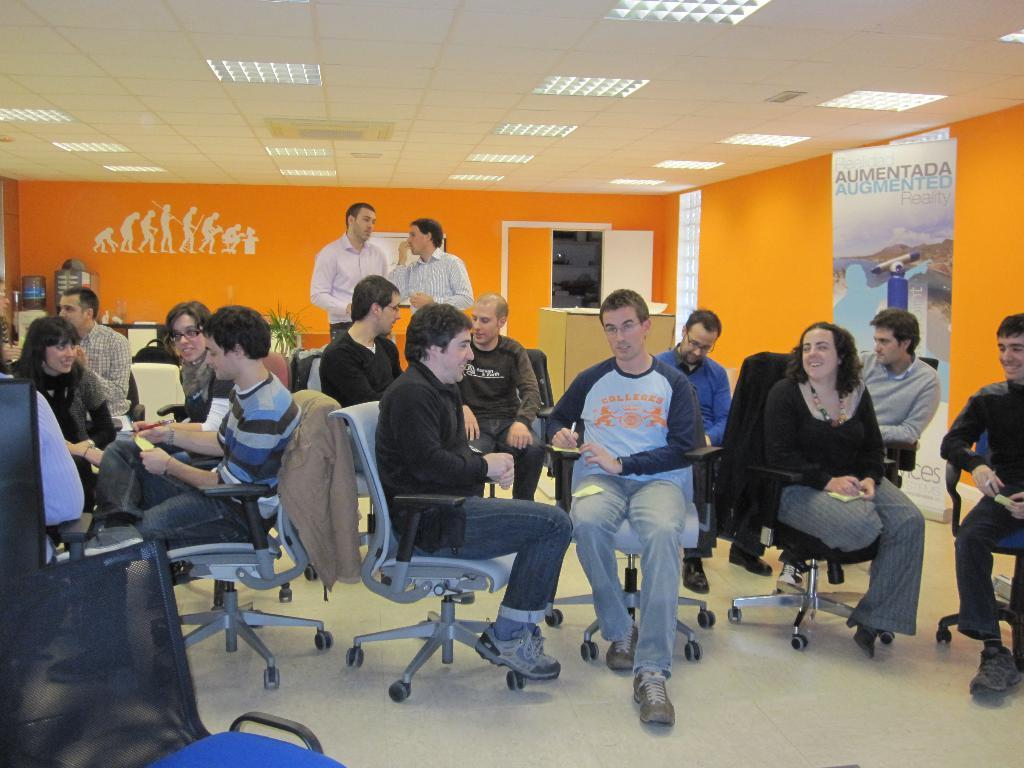What are the people in the image doing? The people in the image are sitting on chairs. Are there any people standing in the image? Yes, there are two people standing in the image. What can be seen on the wall or background in the image? There is a poster visible in the image. What type of drain is visible in the image in the image? There is no drain present in the image. Can you tell me what is on the page that the people are reading in the image? There is no page or reading material visible in the image. 